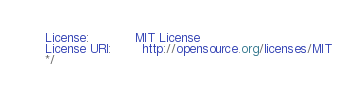Convert code to text. <code><loc_0><loc_0><loc_500><loc_500><_CSS_>License:            MIT License
License URI:        http://opensource.org/licenses/MIT
*/
</code> 